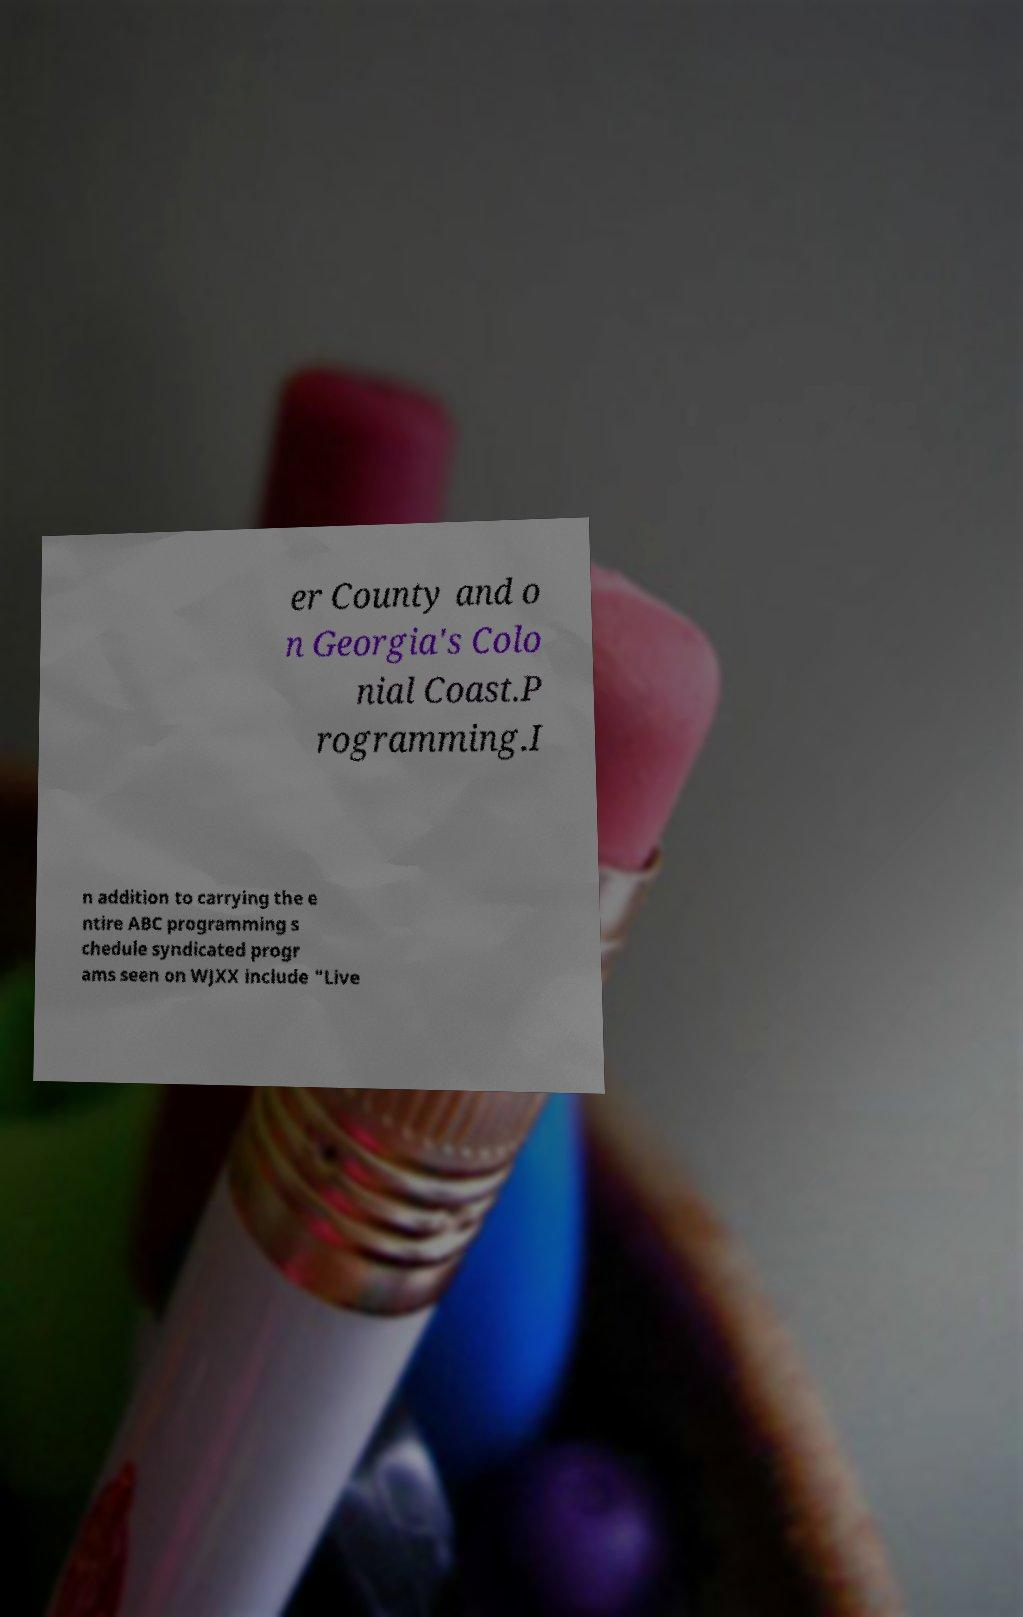Could you assist in decoding the text presented in this image and type it out clearly? er County and o n Georgia's Colo nial Coast.P rogramming.I n addition to carrying the e ntire ABC programming s chedule syndicated progr ams seen on WJXX include "Live 